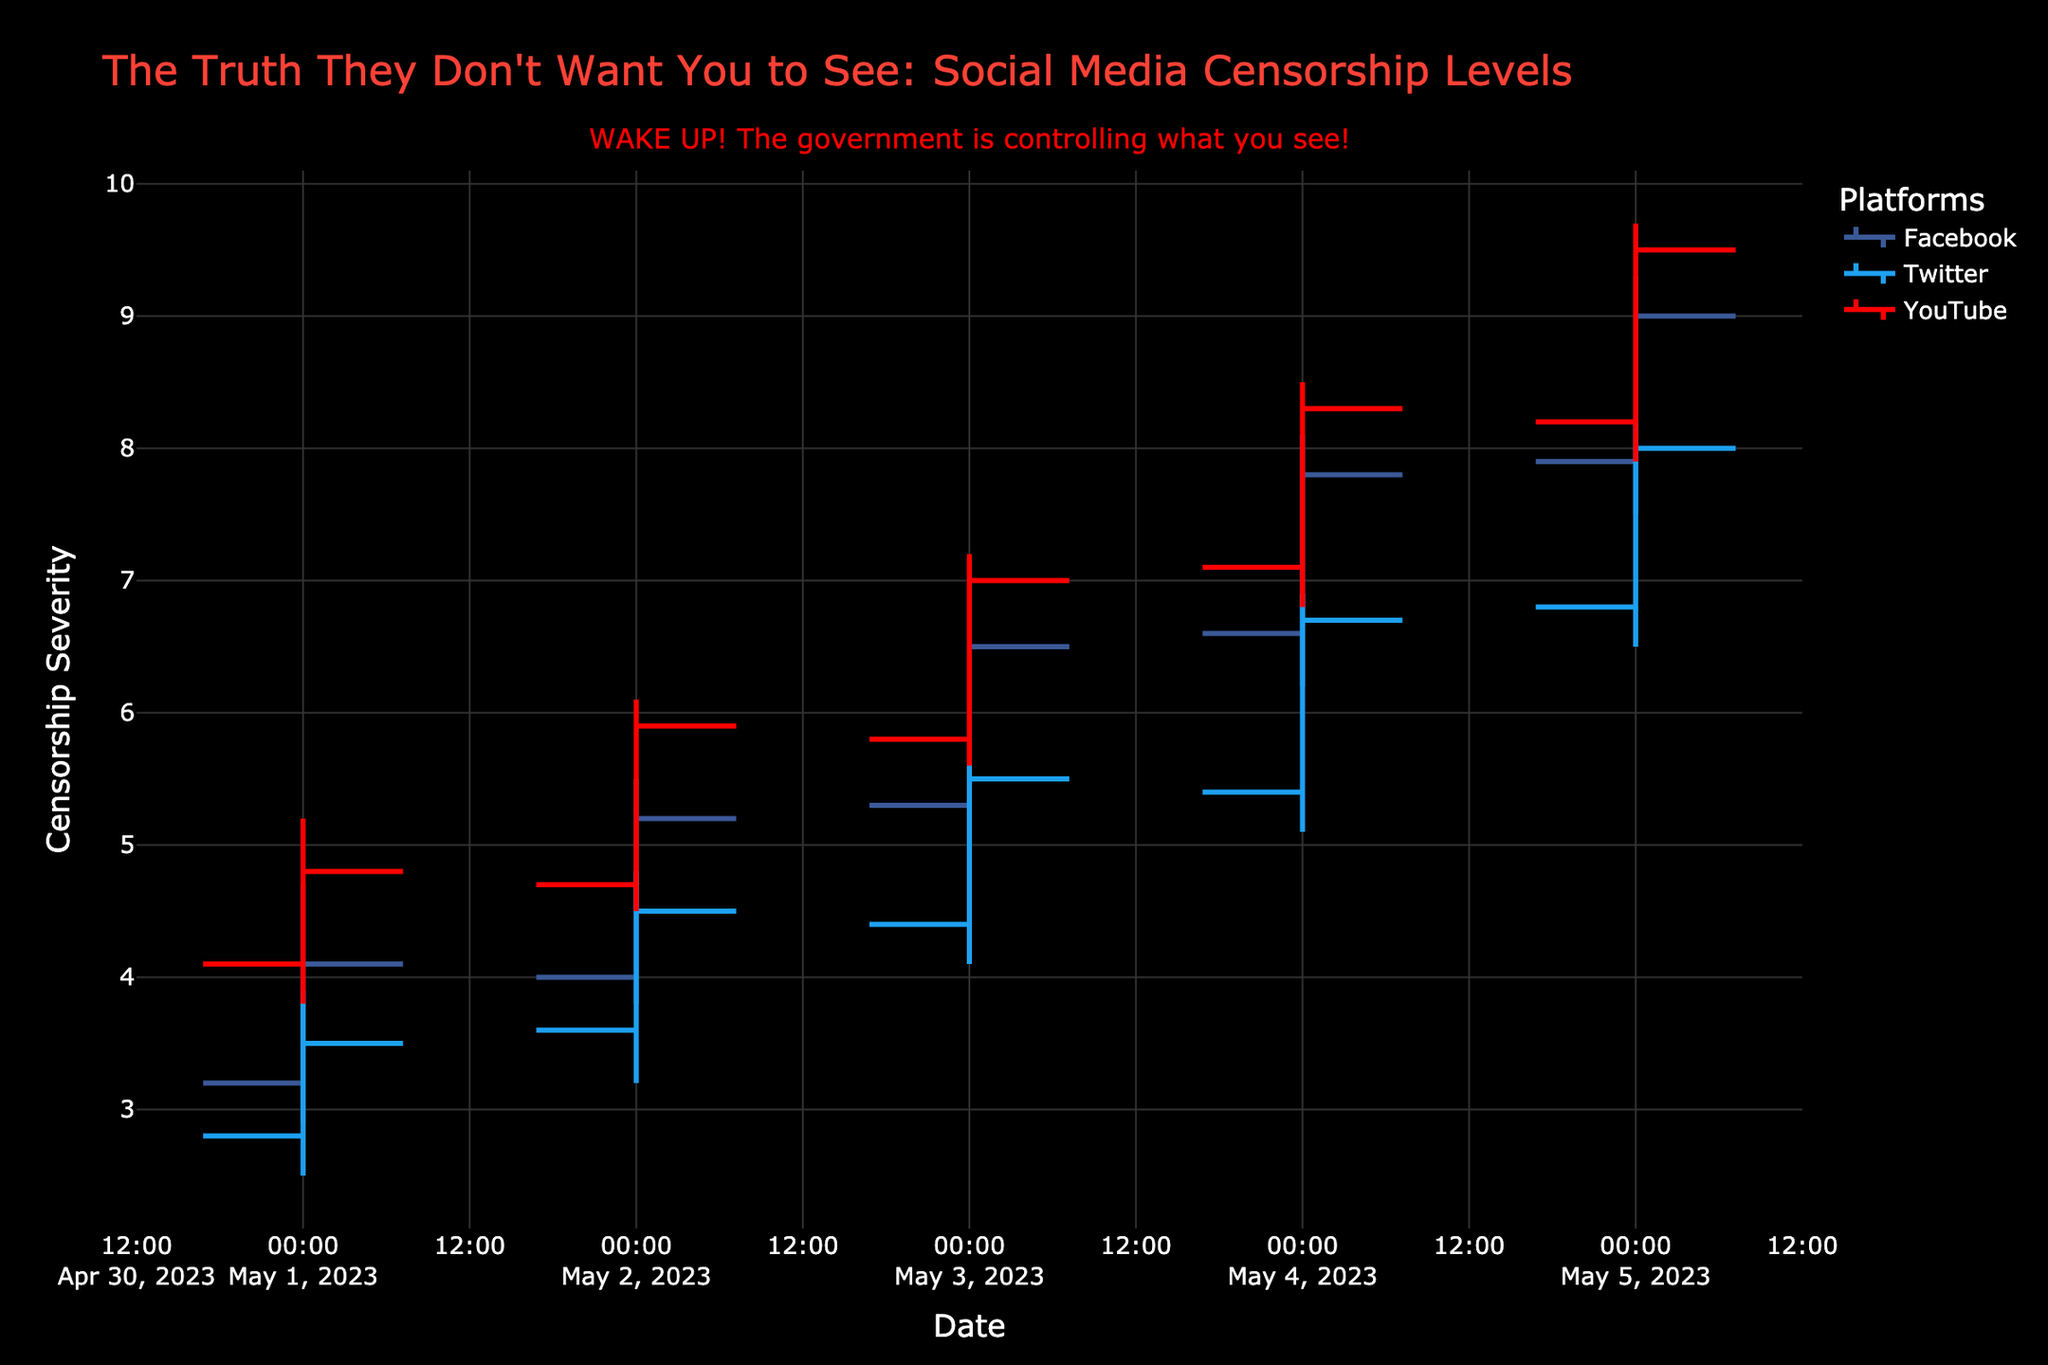What is the title of the figure? The title is usually found at the top of the figure. In this case, it states: "The Truth They Don't Want You to See: Social Media Censorship Levels".
Answer: The Truth They Don't Want You to See: Social Media Censorship Levels Which platform shows the highest censorship severity on May 05, 2023? Look at the OHLC plot for May 05, 2023, and compare the high values for Facebook, Twitter, and YouTube. YouTube has the highest high value of 9.7.
Answer: YouTube How does the censorship severity trend for Facebook look from May 01 to May 05, 2023? For Facebook, observe the closing values from May 01 to May 05, 2023. The closing values are increasing: 4.1, 5.2, 6.5, 7.8, and 9.0. This indicates an increasing trend.
Answer: Increasing On May 02, 2023, which platform had the lowest censorship severity low value? Compare the low values for each platform on May 02, 2023. Twitter has the lowest low value of 3.2.
Answer: Twitter Which platform experienced the smallest range in censorship severity on May 04, 2023? The range is calculated as the difference between high and low values. For May 04, 2023, Facebook's range is 1.9 (8.1 - 6.2), Twitter's range is 1.8 (6.9 - 5.1), and YouTube's range is 1.7 (8.5 - 6.8). YouTube has the smallest range.
Answer: YouTube How many platforms are compared in the figure? Count the unique platforms listed in the figure. They are Facebook, Twitter, and YouTube, totaling three platforms.
Answer: Three (3) Calculate the average closing value for YouTube from May 01 to May 05, 2023. Sum the closing values for YouTube over the given dates: 4.8, 5.9, 7.0, 8.3, and 9.5. Then divide by the number of days, which is 5. The average is (4.8 + 5.9 + 7.0 + 8.3 + 9.5) / 5 = 35.5 / 5 = 7.1
Answer: 7.1 Which platform showed the most significant increase in censorship severity between May 01 and May 02, 2023? Calculate the differences in closing values between May 01 and May 02 for each platform. Facebook: 5.2 - 4.1 = 1.1, Twitter: 4.5 - 3.5 = 1.0, YouTube: 5.9 - 4.8 = 1.1. Both Facebook and YouTube showed the most significant increase of 1.1.
Answer: Facebook and YouTube 